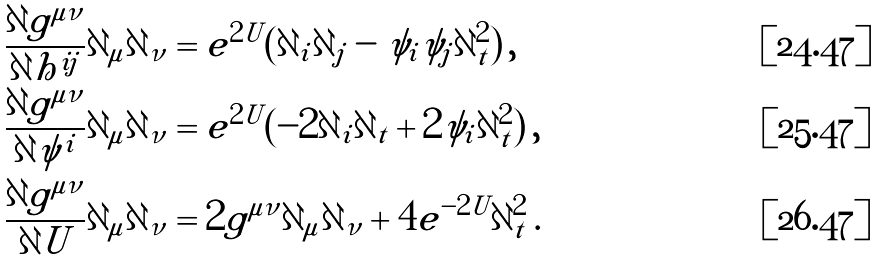Convert formula to latex. <formula><loc_0><loc_0><loc_500><loc_500>\frac { \partial g ^ { \mu \nu } } { \partial h ^ { i j } } \partial _ { \mu } \partial _ { \nu } & = e ^ { 2 U } ( \partial _ { i } \partial _ { j } - \psi _ { i } \psi _ { j } \partial _ { t } ^ { 2 } ) \, , \\ \frac { \partial g ^ { \mu \nu } } { \partial \psi ^ { i } } \partial _ { \mu } \partial _ { \nu } & = e ^ { 2 U } ( - 2 \partial _ { i } \partial _ { t } + 2 \psi _ { i } \partial _ { t } ^ { 2 } ) \, , \\ \frac { \partial g ^ { \mu \nu } } { \partial U } \partial _ { \mu } \partial _ { \nu } & = 2 g ^ { \mu \nu } \partial _ { \mu } \partial _ { \nu } + 4 e ^ { - 2 U } \partial _ { t } ^ { 2 } \, .</formula> 